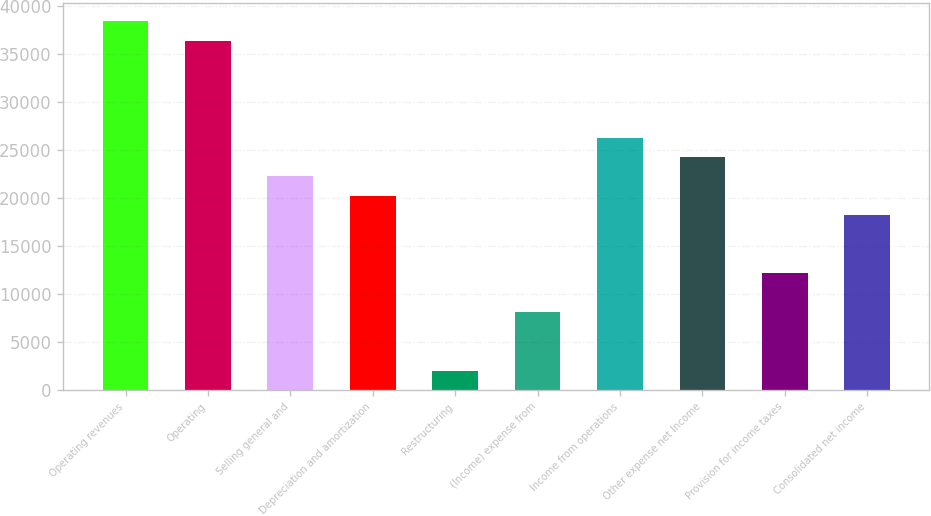Convert chart to OTSL. <chart><loc_0><loc_0><loc_500><loc_500><bar_chart><fcel>Operating revenues<fcel>Operating<fcel>Selling general and<fcel>Depreciation and amortization<fcel>Restructuring<fcel>(Income) expense from<fcel>Income from operations<fcel>Other expense net Income<fcel>Provision for income taxes<fcel>Consolidated net income<nl><fcel>38430.3<fcel>36407.7<fcel>22249.6<fcel>20227<fcel>2023.67<fcel>8091.44<fcel>26294.8<fcel>24272.2<fcel>12136.6<fcel>18204.4<nl></chart> 